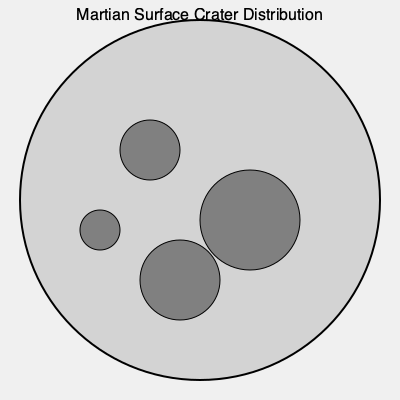Based on the satellite imagery of Martian crater distribution shown above, what can be inferred about the age and geological history of this region? Consider crater size, density, and distribution patterns in your analysis. 1. Crater size analysis:
   - The image shows craters of varying sizes, ranging from small (r ≈ 20 units) to large (r ≈ 50 units).
   - Larger craters generally indicate older surfaces or higher-energy impacts.

2. Crater density:
   - The image shows a moderate density of craters, with approximately 4 visible craters.
   - Higher crater density typically suggests an older surface.

3. Distribution pattern:
   - Craters appear randomly distributed across the surface.
   - No clear clustering or alignment is observed.

4. Crater morphology:
   - All craters appear circular, suggesting relatively recent formation or minimal erosion.
   - No obvious signs of degradation or infilling are visible.

5. Surface age estimation:
   - The presence of both large and small craters suggests a surface of intermediate age.
   - The moderate crater density supports this interpretation.

6. Geological history interpretation:
   - The variety in crater sizes indicates multiple impact events over time.
   - The lack of heavily degraded craters suggests relatively recent geological activity or resurfacing.

7. Potential biases:
   - Limited field of view may not represent the entire region.
   - Resolution constraints may obscure smaller craters or subtle features.

Conclusion:
The region appears to be of intermediate age, with a history of multiple impact events. The surface has likely undergone some geological processes to maintain the circular crater morphology, but has been relatively stable in recent geological time to preserve the observed crater distribution.
Answer: Intermediate-aged surface with multiple impact events and recent geological stability 